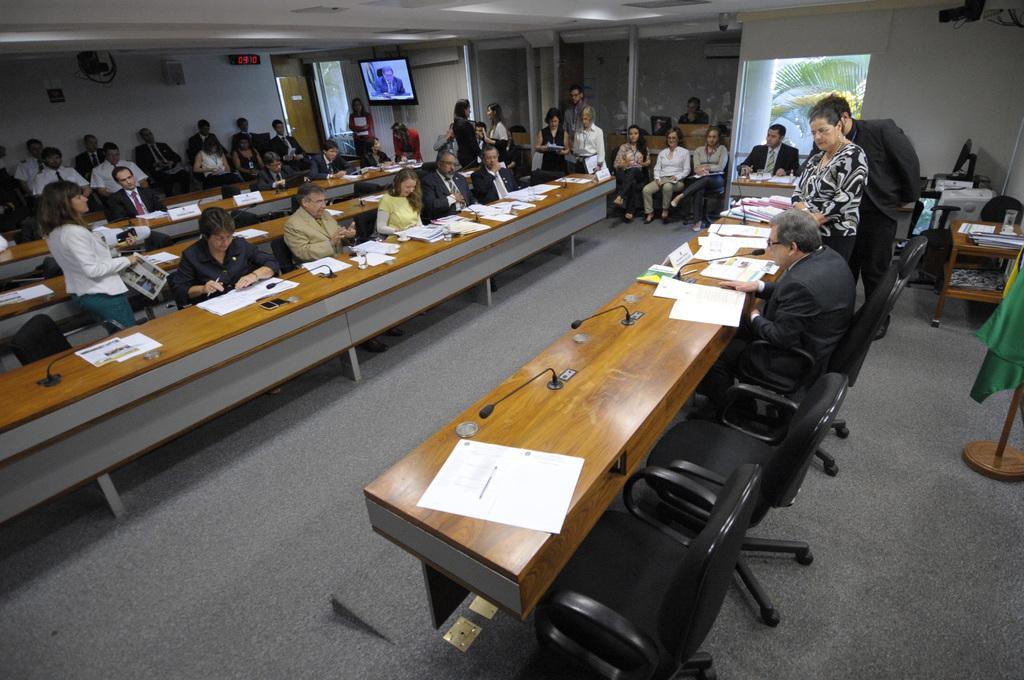How would you summarize this image in a sentence or two? As we can see in the image there is a white color wall, doors, screen, window, tree and few people sitting on chairs and there is a table. On table there are papers, mics, glasses. 